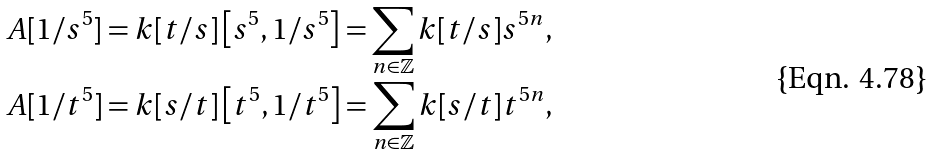Convert formula to latex. <formula><loc_0><loc_0><loc_500><loc_500>& A [ 1 / s ^ { 5 } ] = k [ t / s ] \left [ s ^ { 5 } , 1 / s ^ { 5 } \right ] = \sum _ { n \in \mathbb { Z } } k [ t / s ] s ^ { 5 n } , \\ & A [ 1 / t ^ { 5 } ] = k [ s / t ] \left [ t ^ { 5 } , 1 / t ^ { 5 } \right ] = \sum _ { n \in \mathbb { Z } } k [ s / t ] t ^ { 5 n } ,</formula> 